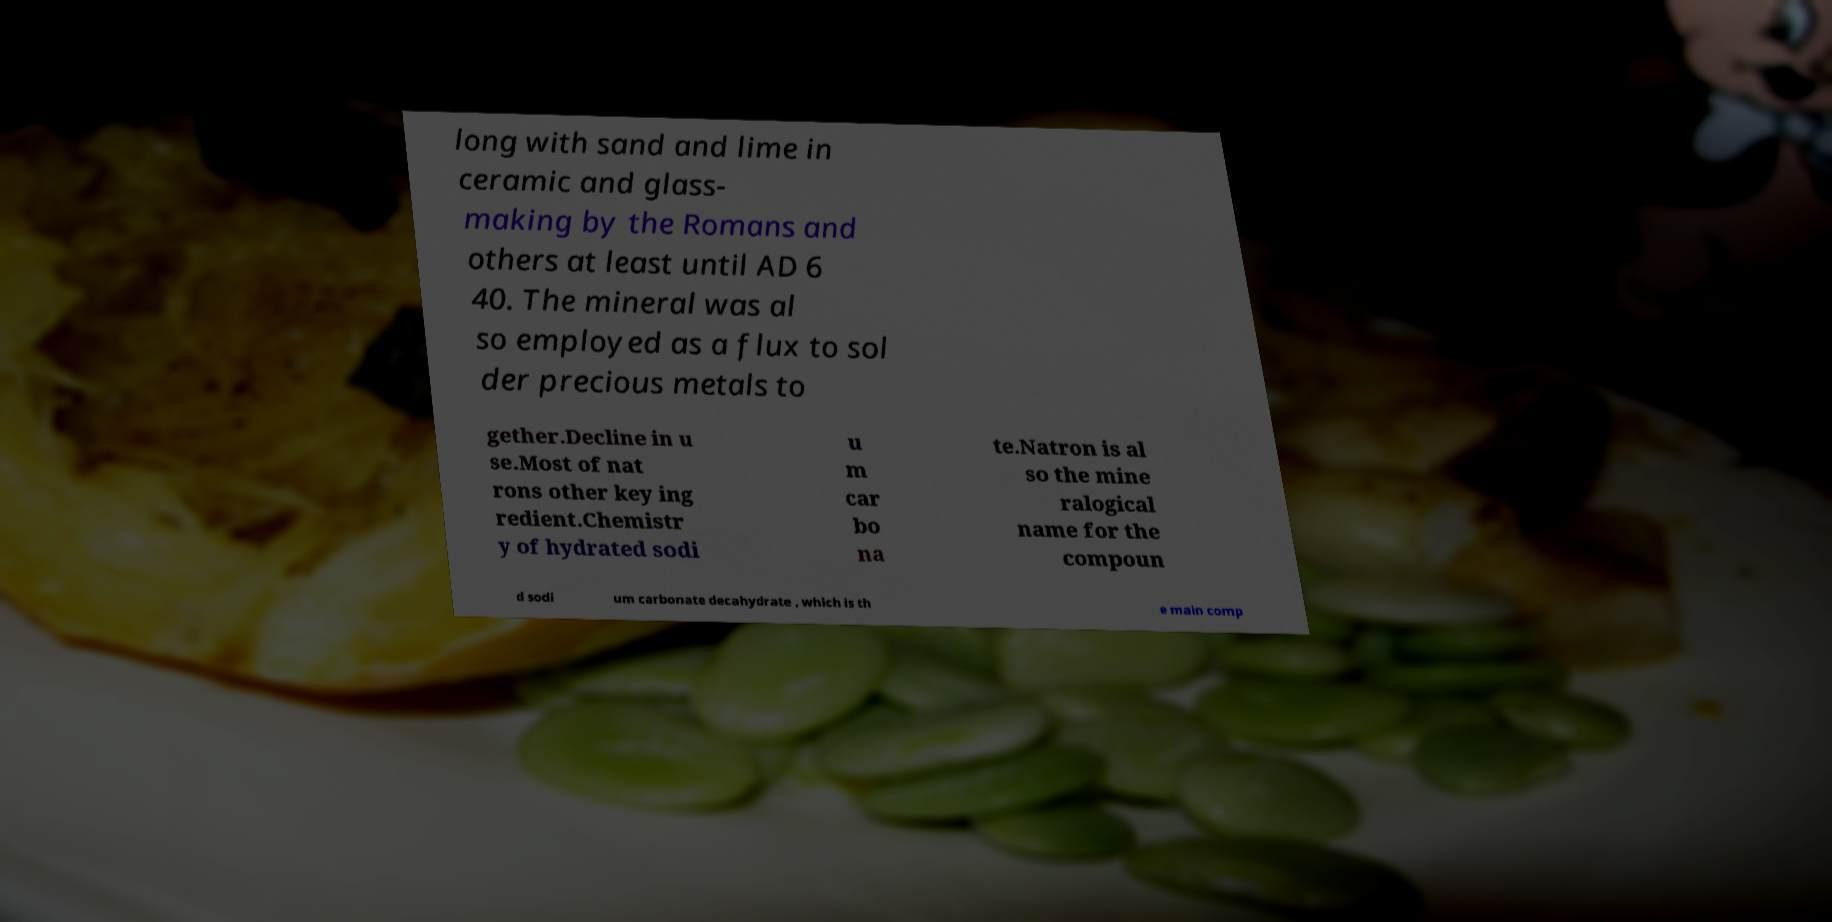What messages or text are displayed in this image? I need them in a readable, typed format. long with sand and lime in ceramic and glass- making by the Romans and others at least until AD 6 40. The mineral was al so employed as a flux to sol der precious metals to gether.Decline in u se.Most of nat rons other key ing redient.Chemistr y of hydrated sodi u m car bo na te.Natron is al so the mine ralogical name for the compoun d sodi um carbonate decahydrate , which is th e main comp 